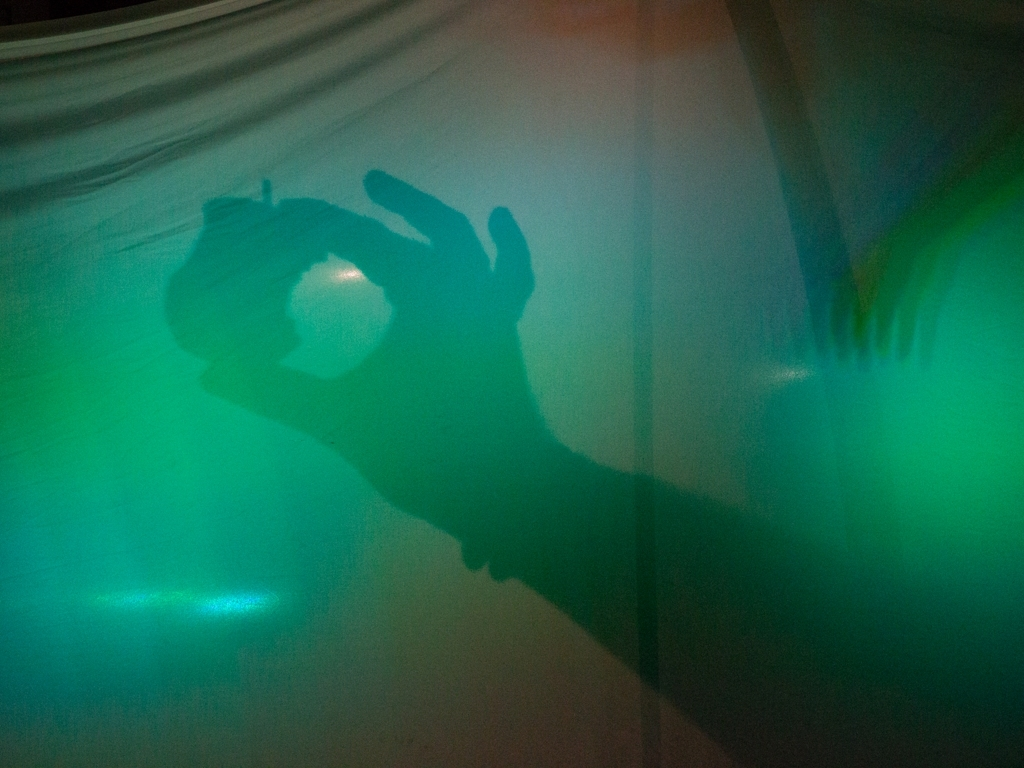What emotion does the shadow in this image evoke? The shadow in the image, characterized by a hand gesture, might evoke a sense of mystery or suspense. Its shape and the subtle illumination evoke a narrative that could belong to a suspenseful or dramatic moment. 